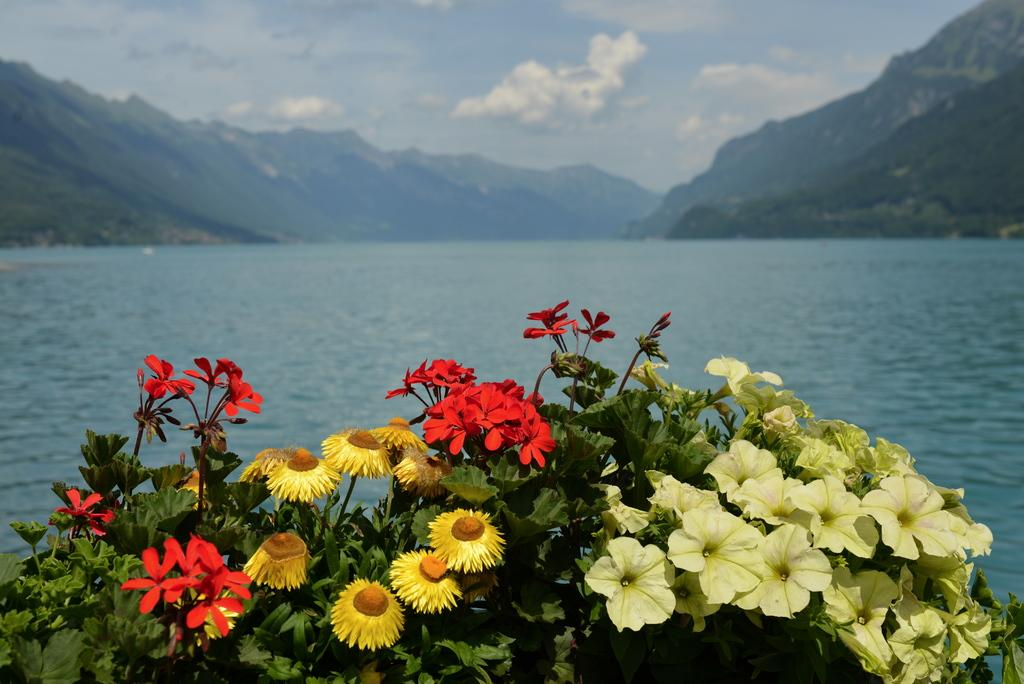What type of plants can be seen in the image? There is a group of flowers and a group of leaves in the image. What is visible in the background of the image? Water, mountains, and a cloudy sky are visible in the background of the image. What language are the flowers speaking in the image? Flowers do not speak any language, so this question cannot be answered. 